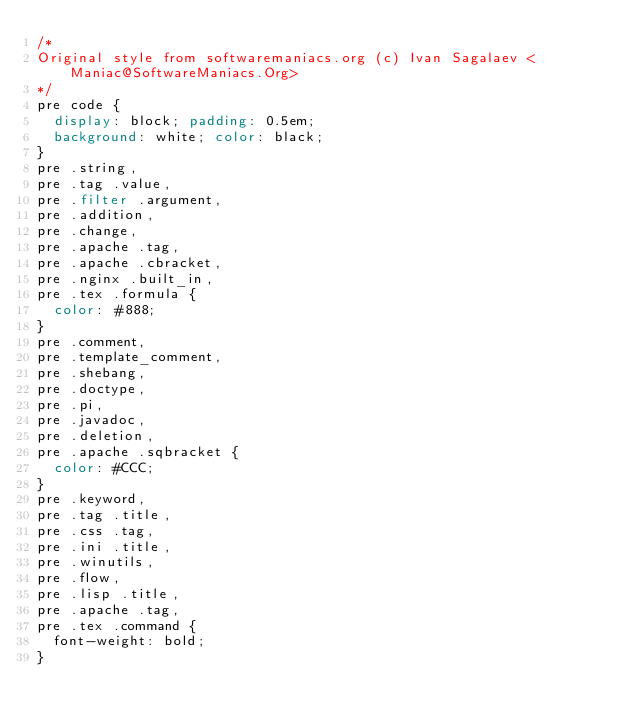Convert code to text. <code><loc_0><loc_0><loc_500><loc_500><_CSS_>/*
Original style from softwaremaniacs.org (c) Ivan Sagalaev <Maniac@SoftwareManiacs.Org>
*/
pre code {
  display: block; padding: 0.5em;
  background: white; color: black;
}
pre .string,
pre .tag .value,
pre .filter .argument,
pre .addition,
pre .change,
pre .apache .tag,
pre .apache .cbracket,
pre .nginx .built_in,
pre .tex .formula {
  color: #888;
}
pre .comment,
pre .template_comment,
pre .shebang,
pre .doctype,
pre .pi,
pre .javadoc,
pre .deletion,
pre .apache .sqbracket {
  color: #CCC;
}
pre .keyword,
pre .tag .title,
pre .css .tag,
pre .ini .title,
pre .winutils,
pre .flow,
pre .lisp .title,
pre .apache .tag,
pre .tex .command {
  font-weight: bold;
}
</code> 